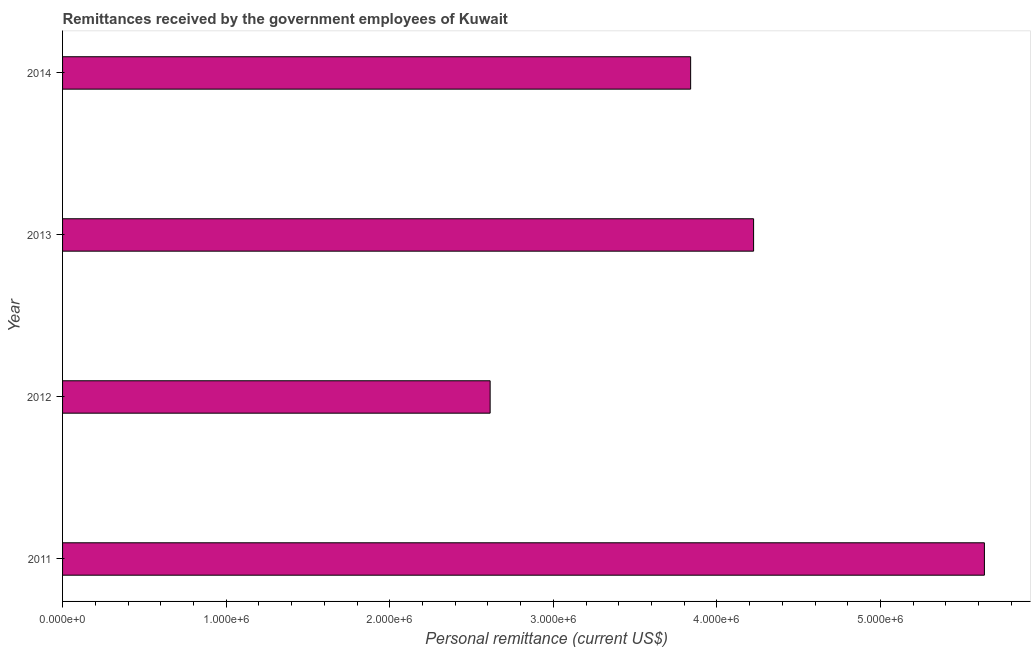Does the graph contain any zero values?
Keep it short and to the point. No. Does the graph contain grids?
Give a very brief answer. No. What is the title of the graph?
Your response must be concise. Remittances received by the government employees of Kuwait. What is the label or title of the X-axis?
Provide a succinct answer. Personal remittance (current US$). What is the label or title of the Y-axis?
Provide a short and direct response. Year. What is the personal remittances in 2012?
Make the answer very short. 2.61e+06. Across all years, what is the maximum personal remittances?
Your answer should be very brief. 5.64e+06. Across all years, what is the minimum personal remittances?
Make the answer very short. 2.61e+06. In which year was the personal remittances maximum?
Offer a terse response. 2011. In which year was the personal remittances minimum?
Make the answer very short. 2012. What is the sum of the personal remittances?
Your answer should be compact. 1.63e+07. What is the difference between the personal remittances in 2011 and 2014?
Your answer should be compact. 1.80e+06. What is the average personal remittances per year?
Keep it short and to the point. 4.08e+06. What is the median personal remittances?
Your answer should be compact. 4.03e+06. What is the ratio of the personal remittances in 2012 to that in 2014?
Make the answer very short. 0.68. What is the difference between the highest and the second highest personal remittances?
Make the answer very short. 1.41e+06. Is the sum of the personal remittances in 2011 and 2012 greater than the maximum personal remittances across all years?
Give a very brief answer. Yes. What is the difference between the highest and the lowest personal remittances?
Offer a terse response. 3.02e+06. In how many years, is the personal remittances greater than the average personal remittances taken over all years?
Offer a terse response. 2. How many bars are there?
Ensure brevity in your answer.  4. How many years are there in the graph?
Your response must be concise. 4. What is the difference between two consecutive major ticks on the X-axis?
Provide a short and direct response. 1.00e+06. Are the values on the major ticks of X-axis written in scientific E-notation?
Make the answer very short. Yes. What is the Personal remittance (current US$) of 2011?
Offer a terse response. 5.64e+06. What is the Personal remittance (current US$) in 2012?
Your response must be concise. 2.61e+06. What is the Personal remittance (current US$) of 2013?
Your answer should be very brief. 4.22e+06. What is the Personal remittance (current US$) of 2014?
Your response must be concise. 3.84e+06. What is the difference between the Personal remittance (current US$) in 2011 and 2012?
Provide a succinct answer. 3.02e+06. What is the difference between the Personal remittance (current US$) in 2011 and 2013?
Ensure brevity in your answer.  1.41e+06. What is the difference between the Personal remittance (current US$) in 2011 and 2014?
Your answer should be compact. 1.80e+06. What is the difference between the Personal remittance (current US$) in 2012 and 2013?
Offer a terse response. -1.61e+06. What is the difference between the Personal remittance (current US$) in 2012 and 2014?
Give a very brief answer. -1.23e+06. What is the difference between the Personal remittance (current US$) in 2013 and 2014?
Provide a succinct answer. 3.85e+05. What is the ratio of the Personal remittance (current US$) in 2011 to that in 2012?
Provide a succinct answer. 2.16. What is the ratio of the Personal remittance (current US$) in 2011 to that in 2013?
Ensure brevity in your answer.  1.33. What is the ratio of the Personal remittance (current US$) in 2011 to that in 2014?
Ensure brevity in your answer.  1.47. What is the ratio of the Personal remittance (current US$) in 2012 to that in 2013?
Provide a short and direct response. 0.62. What is the ratio of the Personal remittance (current US$) in 2012 to that in 2014?
Keep it short and to the point. 0.68. What is the ratio of the Personal remittance (current US$) in 2013 to that in 2014?
Offer a terse response. 1.1. 